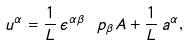<formula> <loc_0><loc_0><loc_500><loc_500>u ^ { \alpha } = \frac { 1 } { L } \, \epsilon ^ { \alpha \beta } \, \ p _ { \beta } A + \frac { 1 } { L } \, a ^ { \alpha } ,</formula> 